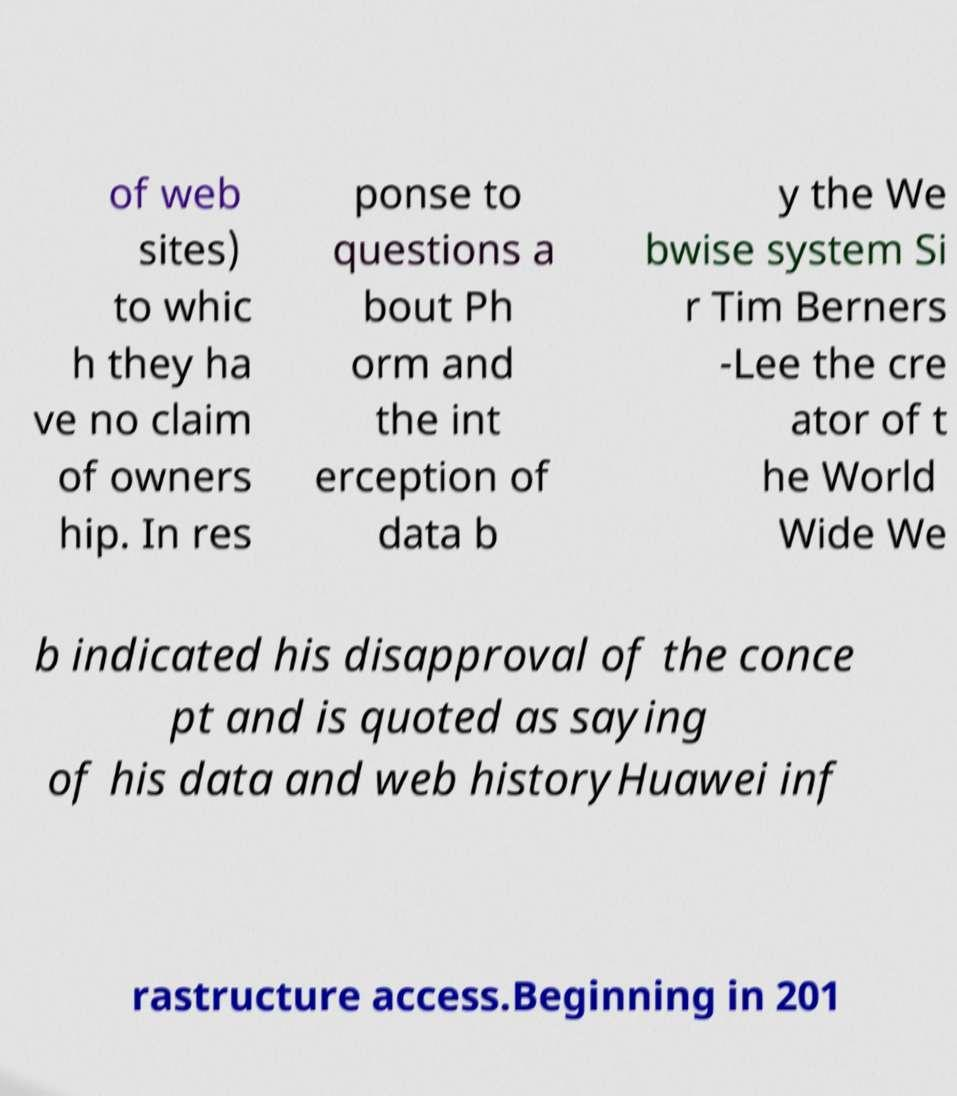Please read and relay the text visible in this image. What does it say? of web sites) to whic h they ha ve no claim of owners hip. In res ponse to questions a bout Ph orm and the int erception of data b y the We bwise system Si r Tim Berners -Lee the cre ator of t he World Wide We b indicated his disapproval of the conce pt and is quoted as saying of his data and web historyHuawei inf rastructure access.Beginning in 201 